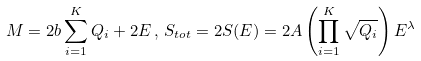Convert formula to latex. <formula><loc_0><loc_0><loc_500><loc_500>M = 2 b \sum _ { i = 1 } ^ { K } Q _ { i } + 2 E \, , \, S _ { t o t } = 2 S ( E ) = 2 A \left ( \prod _ { i = 1 } ^ { K } \sqrt { Q _ { i } } \right ) E ^ { \lambda }</formula> 